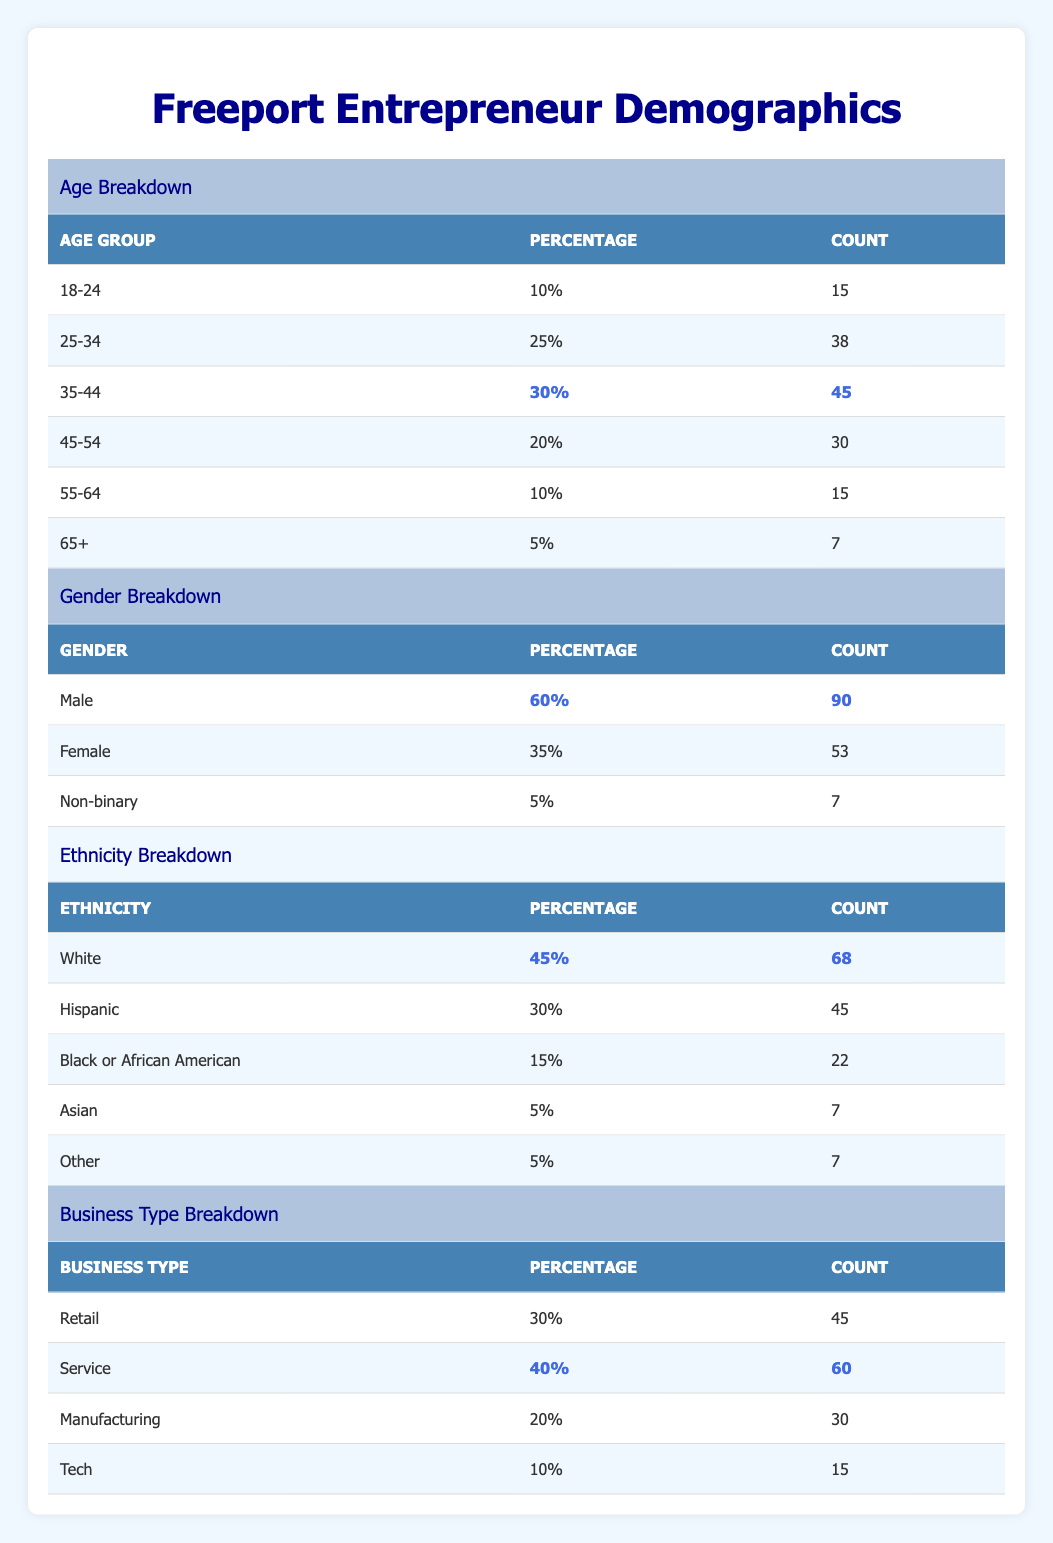What is the total number of entrepreneurs in Freeport? The table states that the total number of entrepreneurs is listed as "Total Entrepreneurs" which is given as 150.
Answer: 150 Which age group has the highest percentage of entrepreneurs? The breakdown of age groups shows that the "35-44" age group has the highest percentage at 30%.
Answer: 35-44 How many female entrepreneurs are there in Freeport? The gender breakdown indicates that there are 53 female entrepreneurs, which is the count listed next to the "Female" category.
Answer: 53 What percentage of entrepreneurs are Hispanic? According to the ethnicity breakdown, the percentage of Hispanic entrepreneurs is indicated as 30%.
Answer: 30% What is the difference in the number of male and female entrepreneurs? The count of male entrepreneurs is 90 and the count of female entrepreneurs is 53. The difference is calculated as 90 - 53 = 37.
Answer: 37 How many entrepreneurs are there in the age group 25-34? The table specifies that there are 38 entrepreneurs in the age group 25-34, which is the count recorded in that row of the age breakdown.
Answer: 38 Are there more entrepreneurs in retail or service businesses? The count for retail entrepreneurs is 45 and for service businesses, it is 60. Since 60 is greater than 45, it indicates there are more entrepreneurs in service businesses.
Answer: Yes What is the total count of entrepreneurs in the age group 55-64 and 65+ combined? The count for the age group 55-64 is 15 and for 65+, it's 7. Adding these counts together gives: 15 + 7 = 22.
Answer: 22 What percentage of entrepreneurs are non-binary? The gender breakdown shows that non-binary entrepreneurs make up 5% of the total, which is specified in the table.
Answer: 5% 